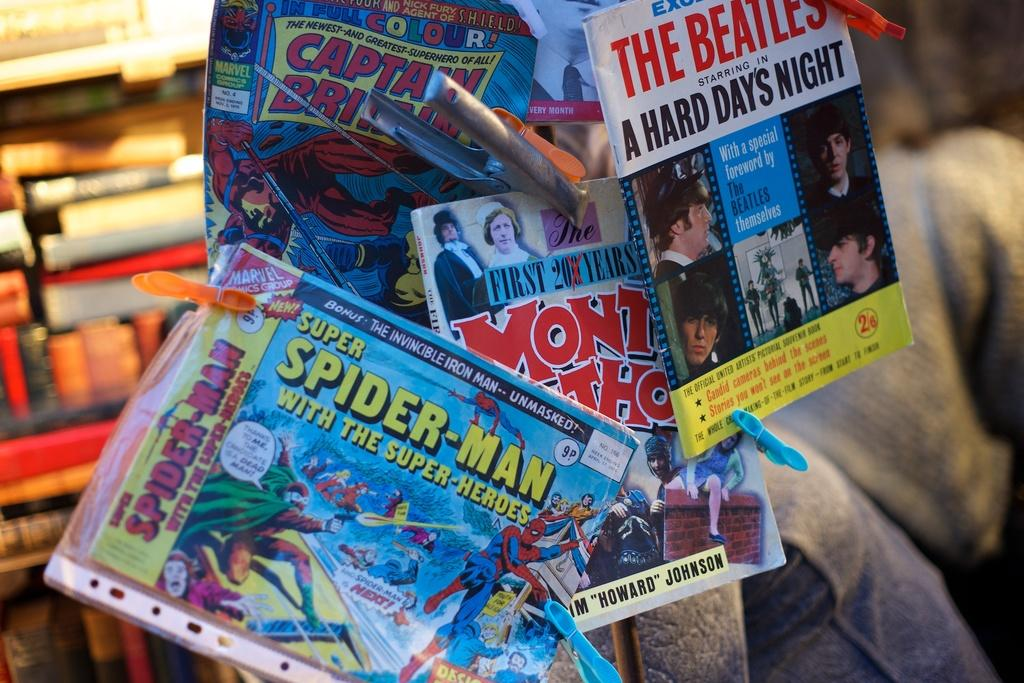Provide a one-sentence caption for the provided image. Several comic books, the frontmost of which features Spider-man. 